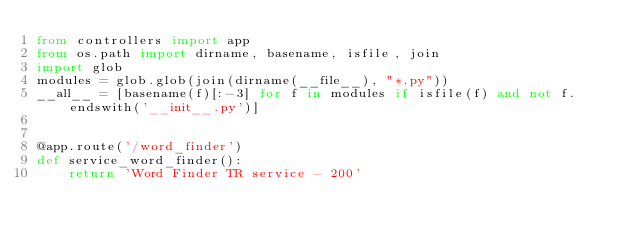<code> <loc_0><loc_0><loc_500><loc_500><_Python_>from controllers import app
from os.path import dirname, basename, isfile, join
import glob
modules = glob.glob(join(dirname(__file__), "*.py"))
__all__ = [basename(f)[:-3] for f in modules if isfile(f) and not f.endswith('__init__.py')]


@app.route('/word_finder')
def service_word_finder():
    return 'Word Finder TR service - 200'
</code> 